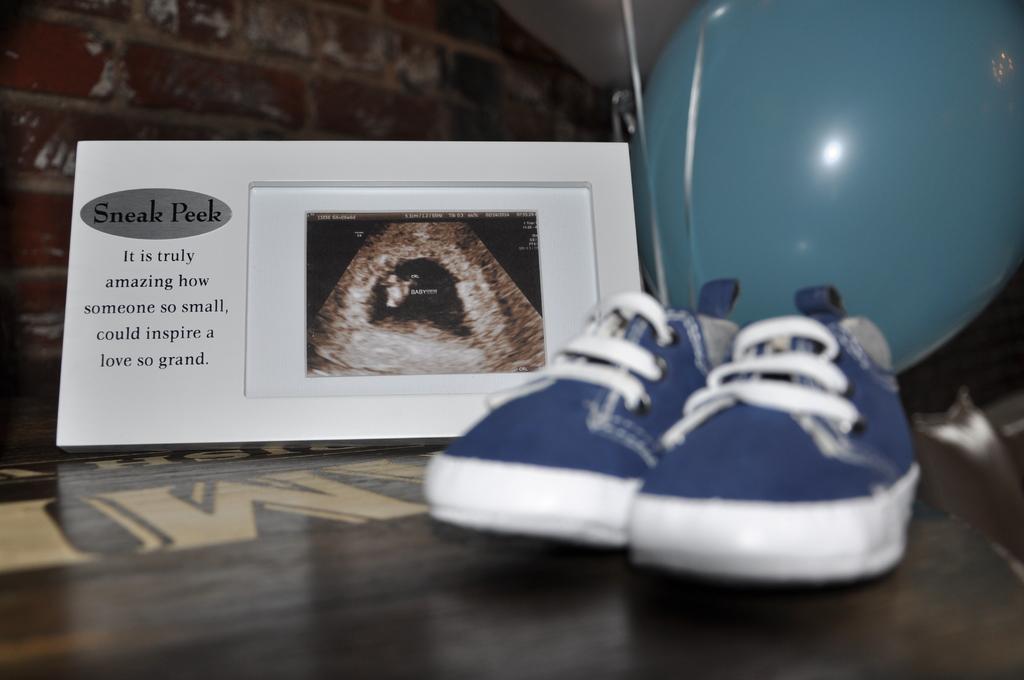Could you give a brief overview of what you see in this image? In this image we can see shoes and photo frame with text and photo. Also there is a balloon. 